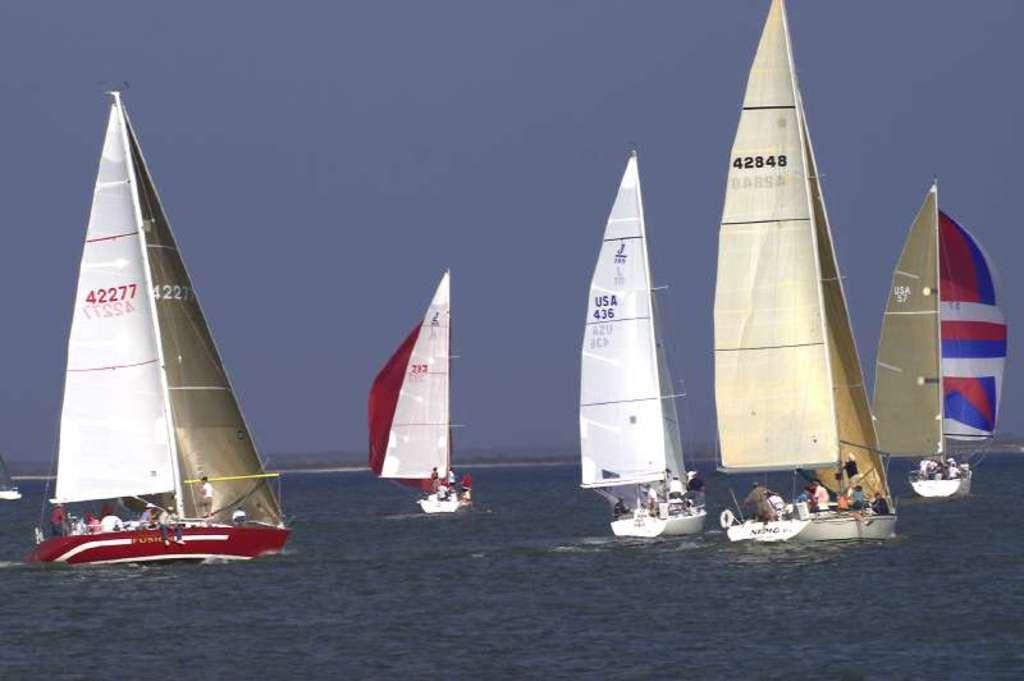Can you describe this image briefly? Here in this picture we can see number of boats present in water and we can also see people sitting and standing in the boat and we can see the sky is cloudy. 